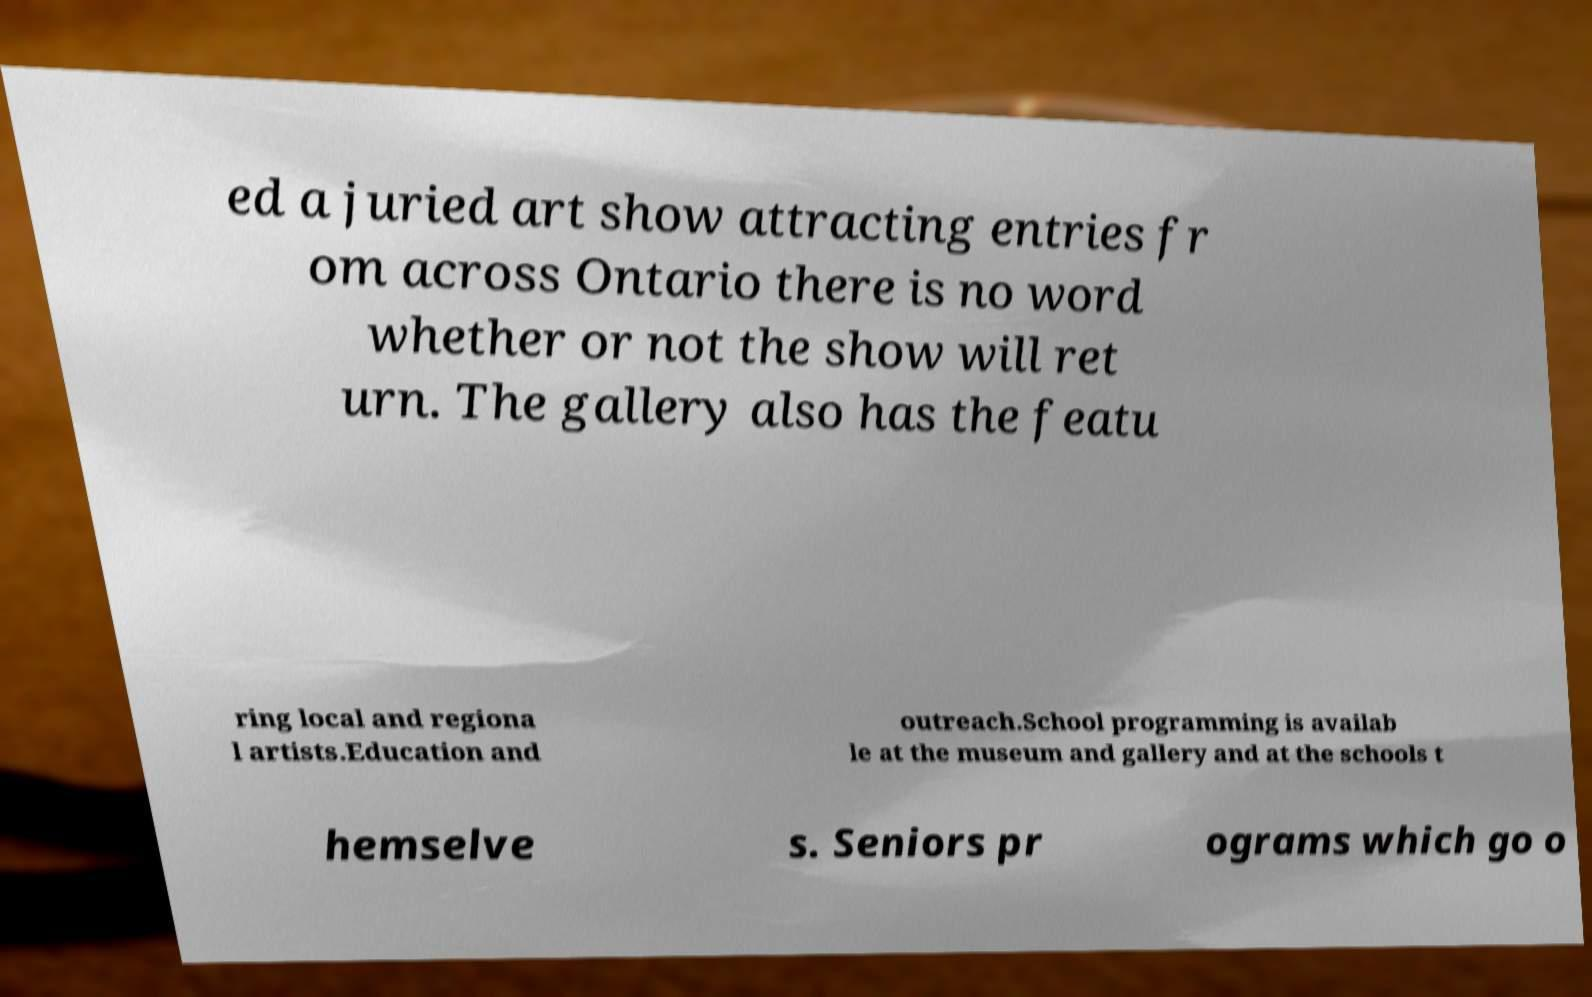Can you accurately transcribe the text from the provided image for me? ed a juried art show attracting entries fr om across Ontario there is no word whether or not the show will ret urn. The gallery also has the featu ring local and regiona l artists.Education and outreach.School programming is availab le at the museum and gallery and at the schools t hemselve s. Seniors pr ograms which go o 